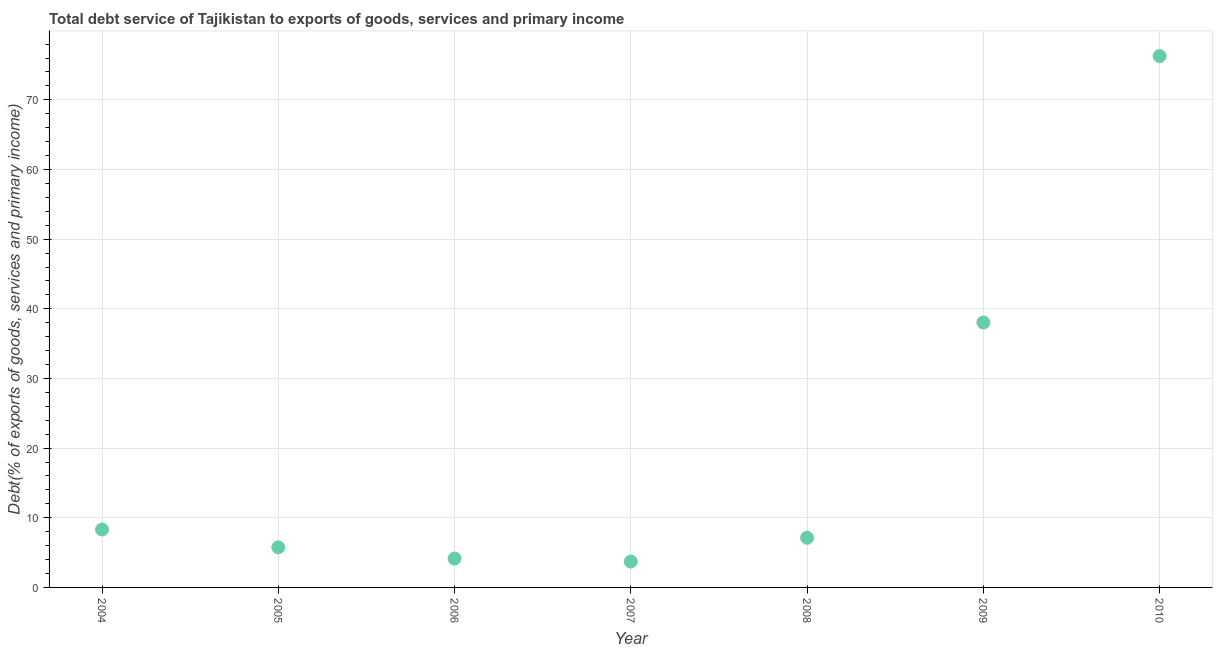What is the total debt service in 2008?
Ensure brevity in your answer.  7.13. Across all years, what is the maximum total debt service?
Your response must be concise. 76.28. Across all years, what is the minimum total debt service?
Offer a terse response. 3.71. What is the sum of the total debt service?
Provide a short and direct response. 143.37. What is the difference between the total debt service in 2008 and 2009?
Keep it short and to the point. -30.91. What is the average total debt service per year?
Keep it short and to the point. 20.48. What is the median total debt service?
Provide a succinct answer. 7.13. In how many years, is the total debt service greater than 46 %?
Ensure brevity in your answer.  1. Do a majority of the years between 2010 and 2005 (inclusive) have total debt service greater than 32 %?
Offer a very short reply. Yes. What is the ratio of the total debt service in 2007 to that in 2008?
Your answer should be very brief. 0.52. Is the difference between the total debt service in 2005 and 2007 greater than the difference between any two years?
Keep it short and to the point. No. What is the difference between the highest and the second highest total debt service?
Provide a short and direct response. 38.24. What is the difference between the highest and the lowest total debt service?
Offer a terse response. 72.57. Does the total debt service monotonically increase over the years?
Offer a very short reply. No. Are the values on the major ticks of Y-axis written in scientific E-notation?
Offer a very short reply. No. Does the graph contain any zero values?
Ensure brevity in your answer.  No. Does the graph contain grids?
Keep it short and to the point. Yes. What is the title of the graph?
Offer a very short reply. Total debt service of Tajikistan to exports of goods, services and primary income. What is the label or title of the X-axis?
Your answer should be compact. Year. What is the label or title of the Y-axis?
Your answer should be very brief. Debt(% of exports of goods, services and primary income). What is the Debt(% of exports of goods, services and primary income) in 2004?
Your answer should be compact. 8.31. What is the Debt(% of exports of goods, services and primary income) in 2005?
Offer a very short reply. 5.75. What is the Debt(% of exports of goods, services and primary income) in 2006?
Make the answer very short. 4.15. What is the Debt(% of exports of goods, services and primary income) in 2007?
Keep it short and to the point. 3.71. What is the Debt(% of exports of goods, services and primary income) in 2008?
Offer a terse response. 7.13. What is the Debt(% of exports of goods, services and primary income) in 2009?
Ensure brevity in your answer.  38.04. What is the Debt(% of exports of goods, services and primary income) in 2010?
Keep it short and to the point. 76.28. What is the difference between the Debt(% of exports of goods, services and primary income) in 2004 and 2005?
Provide a succinct answer. 2.56. What is the difference between the Debt(% of exports of goods, services and primary income) in 2004 and 2006?
Provide a succinct answer. 4.17. What is the difference between the Debt(% of exports of goods, services and primary income) in 2004 and 2007?
Ensure brevity in your answer.  4.6. What is the difference between the Debt(% of exports of goods, services and primary income) in 2004 and 2008?
Give a very brief answer. 1.19. What is the difference between the Debt(% of exports of goods, services and primary income) in 2004 and 2009?
Your response must be concise. -29.72. What is the difference between the Debt(% of exports of goods, services and primary income) in 2004 and 2010?
Your answer should be compact. -67.97. What is the difference between the Debt(% of exports of goods, services and primary income) in 2005 and 2006?
Offer a terse response. 1.61. What is the difference between the Debt(% of exports of goods, services and primary income) in 2005 and 2007?
Offer a terse response. 2.04. What is the difference between the Debt(% of exports of goods, services and primary income) in 2005 and 2008?
Give a very brief answer. -1.37. What is the difference between the Debt(% of exports of goods, services and primary income) in 2005 and 2009?
Your response must be concise. -32.28. What is the difference between the Debt(% of exports of goods, services and primary income) in 2005 and 2010?
Ensure brevity in your answer.  -70.52. What is the difference between the Debt(% of exports of goods, services and primary income) in 2006 and 2007?
Offer a very short reply. 0.44. What is the difference between the Debt(% of exports of goods, services and primary income) in 2006 and 2008?
Provide a succinct answer. -2.98. What is the difference between the Debt(% of exports of goods, services and primary income) in 2006 and 2009?
Your answer should be compact. -33.89. What is the difference between the Debt(% of exports of goods, services and primary income) in 2006 and 2010?
Give a very brief answer. -72.13. What is the difference between the Debt(% of exports of goods, services and primary income) in 2007 and 2008?
Make the answer very short. -3.42. What is the difference between the Debt(% of exports of goods, services and primary income) in 2007 and 2009?
Give a very brief answer. -34.33. What is the difference between the Debt(% of exports of goods, services and primary income) in 2007 and 2010?
Offer a very short reply. -72.57. What is the difference between the Debt(% of exports of goods, services and primary income) in 2008 and 2009?
Give a very brief answer. -30.91. What is the difference between the Debt(% of exports of goods, services and primary income) in 2008 and 2010?
Your answer should be very brief. -69.15. What is the difference between the Debt(% of exports of goods, services and primary income) in 2009 and 2010?
Keep it short and to the point. -38.24. What is the ratio of the Debt(% of exports of goods, services and primary income) in 2004 to that in 2005?
Ensure brevity in your answer.  1.44. What is the ratio of the Debt(% of exports of goods, services and primary income) in 2004 to that in 2006?
Offer a very short reply. 2. What is the ratio of the Debt(% of exports of goods, services and primary income) in 2004 to that in 2007?
Provide a short and direct response. 2.24. What is the ratio of the Debt(% of exports of goods, services and primary income) in 2004 to that in 2008?
Provide a short and direct response. 1.17. What is the ratio of the Debt(% of exports of goods, services and primary income) in 2004 to that in 2009?
Offer a very short reply. 0.22. What is the ratio of the Debt(% of exports of goods, services and primary income) in 2004 to that in 2010?
Provide a short and direct response. 0.11. What is the ratio of the Debt(% of exports of goods, services and primary income) in 2005 to that in 2006?
Ensure brevity in your answer.  1.39. What is the ratio of the Debt(% of exports of goods, services and primary income) in 2005 to that in 2007?
Provide a short and direct response. 1.55. What is the ratio of the Debt(% of exports of goods, services and primary income) in 2005 to that in 2008?
Your answer should be compact. 0.81. What is the ratio of the Debt(% of exports of goods, services and primary income) in 2005 to that in 2009?
Give a very brief answer. 0.15. What is the ratio of the Debt(% of exports of goods, services and primary income) in 2005 to that in 2010?
Your answer should be very brief. 0.07. What is the ratio of the Debt(% of exports of goods, services and primary income) in 2006 to that in 2007?
Your response must be concise. 1.12. What is the ratio of the Debt(% of exports of goods, services and primary income) in 2006 to that in 2008?
Ensure brevity in your answer.  0.58. What is the ratio of the Debt(% of exports of goods, services and primary income) in 2006 to that in 2009?
Make the answer very short. 0.11. What is the ratio of the Debt(% of exports of goods, services and primary income) in 2006 to that in 2010?
Offer a terse response. 0.05. What is the ratio of the Debt(% of exports of goods, services and primary income) in 2007 to that in 2008?
Your answer should be compact. 0.52. What is the ratio of the Debt(% of exports of goods, services and primary income) in 2007 to that in 2009?
Ensure brevity in your answer.  0.1. What is the ratio of the Debt(% of exports of goods, services and primary income) in 2007 to that in 2010?
Your answer should be compact. 0.05. What is the ratio of the Debt(% of exports of goods, services and primary income) in 2008 to that in 2009?
Provide a succinct answer. 0.19. What is the ratio of the Debt(% of exports of goods, services and primary income) in 2008 to that in 2010?
Give a very brief answer. 0.09. What is the ratio of the Debt(% of exports of goods, services and primary income) in 2009 to that in 2010?
Make the answer very short. 0.5. 